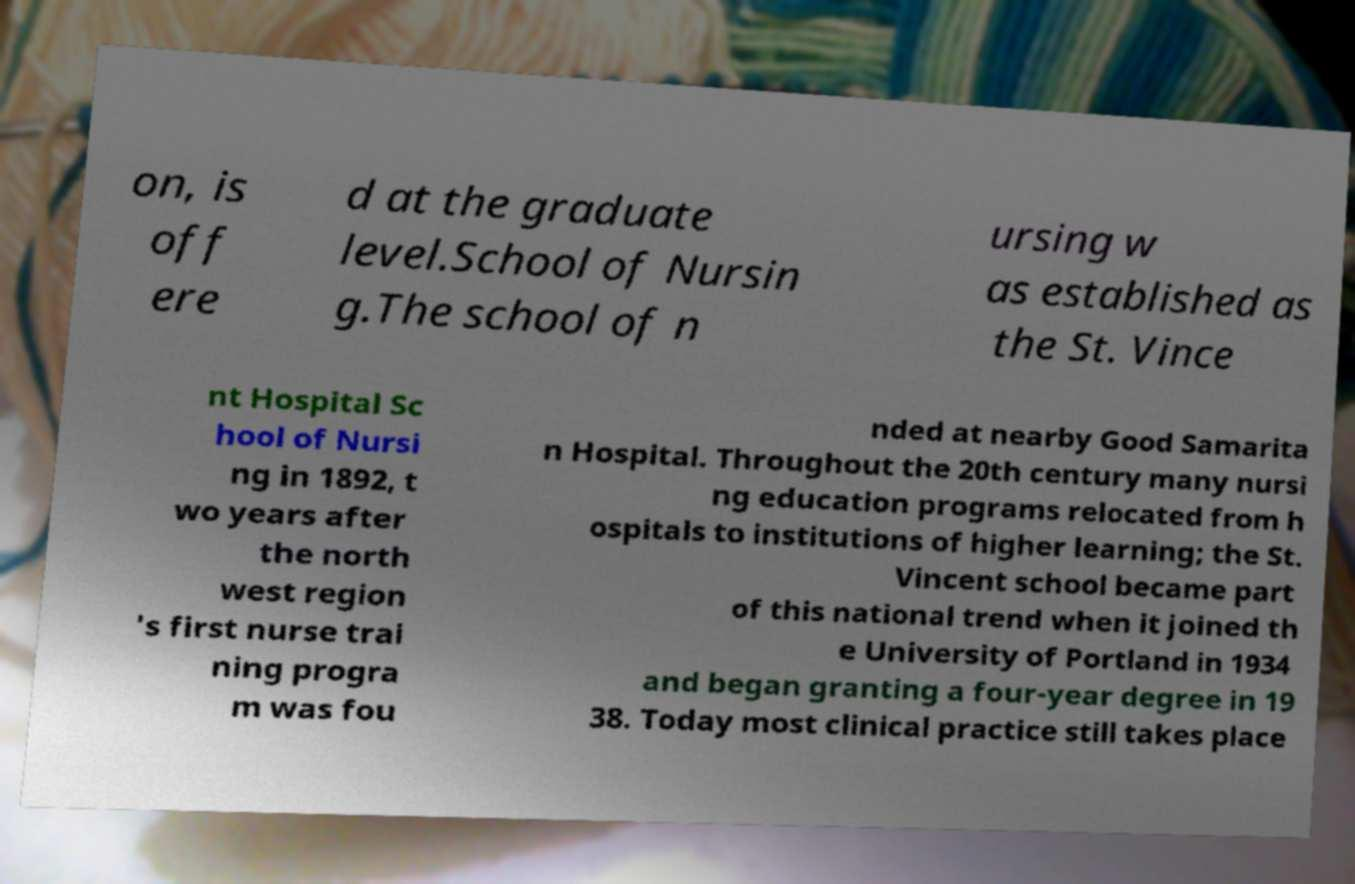I need the written content from this picture converted into text. Can you do that? on, is off ere d at the graduate level.School of Nursin g.The school of n ursing w as established as the St. Vince nt Hospital Sc hool of Nursi ng in 1892, t wo years after the north west region 's first nurse trai ning progra m was fou nded at nearby Good Samarita n Hospital. Throughout the 20th century many nursi ng education programs relocated from h ospitals to institutions of higher learning; the St. Vincent school became part of this national trend when it joined th e University of Portland in 1934 and began granting a four-year degree in 19 38. Today most clinical practice still takes place 